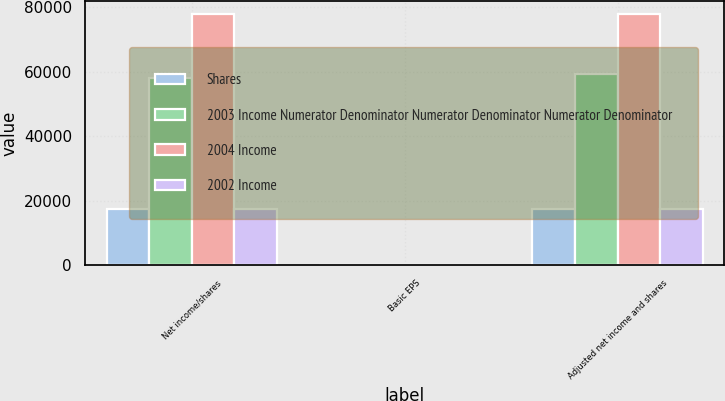<chart> <loc_0><loc_0><loc_500><loc_500><stacked_bar_chart><ecel><fcel>Net income/shares<fcel>Basic EPS<fcel>Adjusted net income and shares<nl><fcel>Shares<fcel>17652<fcel>5.64<fcel>17652<nl><fcel>2003 Income Numerator Denominator Numerator Denominator Numerator Denominator<fcel>58275<fcel>5.64<fcel>59226<nl><fcel>2004 Income<fcel>77992<fcel>1.37<fcel>77992<nl><fcel>2002 Income<fcel>17652<fcel>0.31<fcel>17652<nl></chart> 